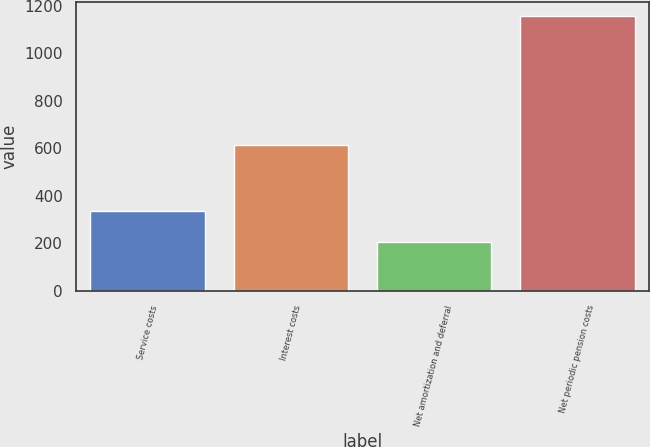Convert chart. <chart><loc_0><loc_0><loc_500><loc_500><bar_chart><fcel>Service costs<fcel>Interest costs<fcel>Net amortization and deferral<fcel>Net periodic pension costs<nl><fcel>335<fcel>614<fcel>207<fcel>1156<nl></chart> 